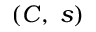Convert formula to latex. <formula><loc_0><loc_0><loc_500><loc_500>( C , \, s )</formula> 